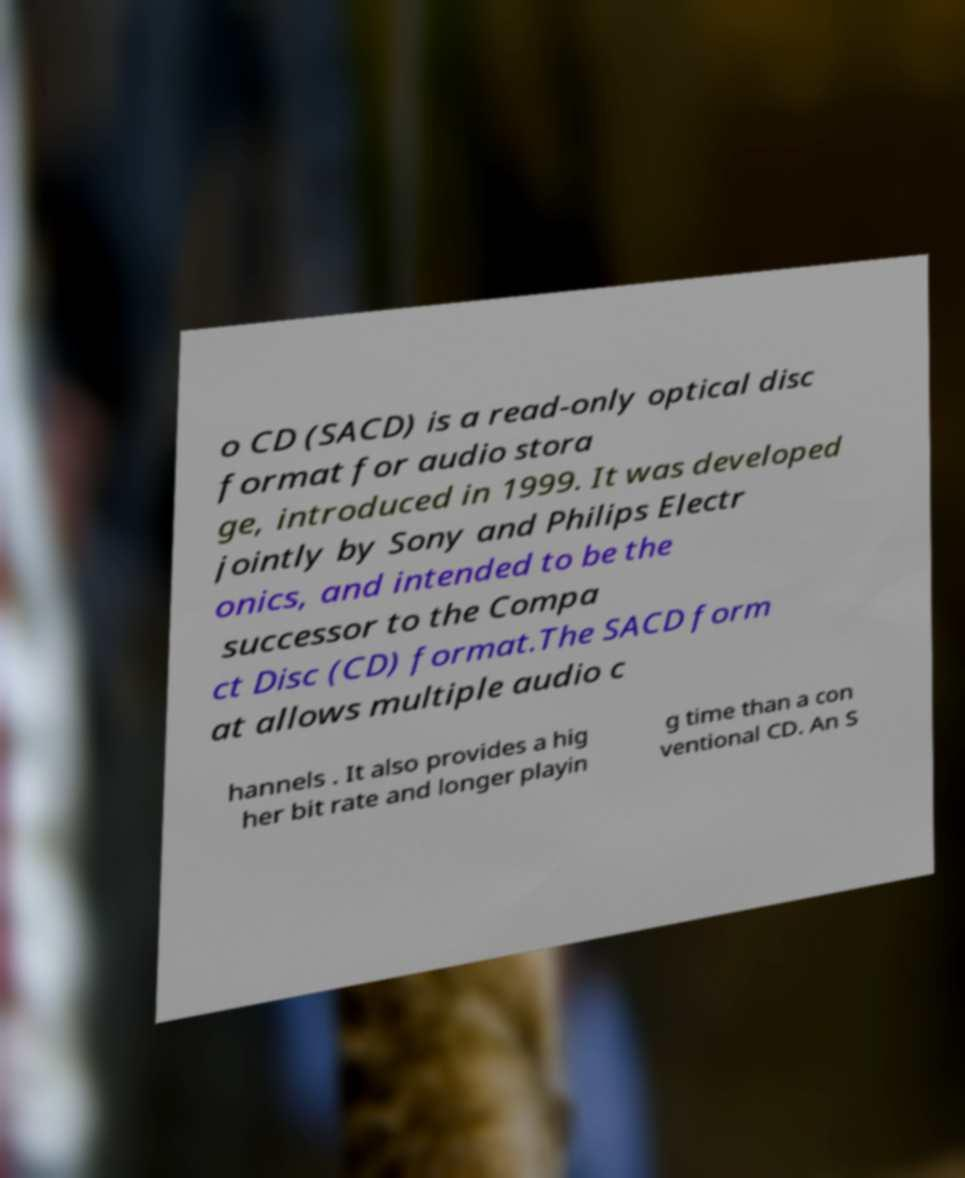Please read and relay the text visible in this image. What does it say? o CD (SACD) is a read-only optical disc format for audio stora ge, introduced in 1999. It was developed jointly by Sony and Philips Electr onics, and intended to be the successor to the Compa ct Disc (CD) format.The SACD form at allows multiple audio c hannels . It also provides a hig her bit rate and longer playin g time than a con ventional CD. An S 